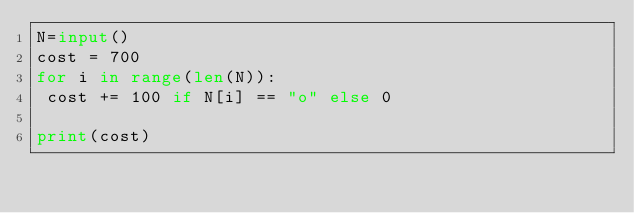<code> <loc_0><loc_0><loc_500><loc_500><_Python_>N=input()
cost = 700
for i in range(len(N)):
 cost += 100 if N[i] == "o" else 0

print(cost)</code> 